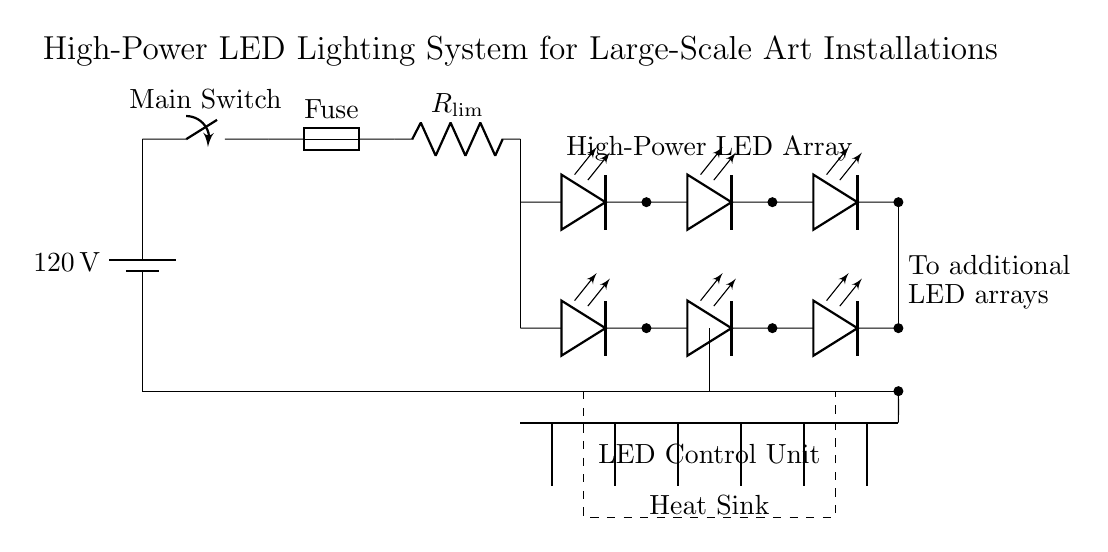What is the power supply voltage? The power supply provides a voltage of 120 volts, as indicated by the battery symbol in the diagram.
Answer: 120 volts What type of switch is used in the circuit? The diagram shows a main switch, which is used to control the flow of electricity in the circuit.
Answer: Main Switch How many LED arrays are present in the circuit? There are a total of two rows of LED arrays shown, one at a higher vertical position and one lower, making it two arrays.
Answer: Two What component is used for current limiting? The component labeled as R_limi_t in the diagram serves to limit the current flowing to the LED arrays, preventing excessive current from damaging them.
Answer: Resistor What is the purpose of the heat sink? The heat sink is used to dissipate heat generated by the LEDs to ensure they operate efficiently and do not overheat, as indicated by its label in the diagram.
Answer: Dissipate heat How is the LED control unit connected in the circuit? The LED control unit is connected above the heat sink and is represented with a dashed rectangle, indicating it controls the operation of the LED arrays while being integrated into the circuit.
Answer: Integrated above the heat sink What is the significance of the fuse in this circuit? The fuse prevents overload by breaking the circuit if the current exceeds a safe level, ensuring safety in operation.
Answer: Prevent overload 